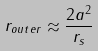<formula> <loc_0><loc_0><loc_500><loc_500>r _ { o u t e r } \approx \frac { 2 a ^ { 2 } } { r _ { s } }</formula> 